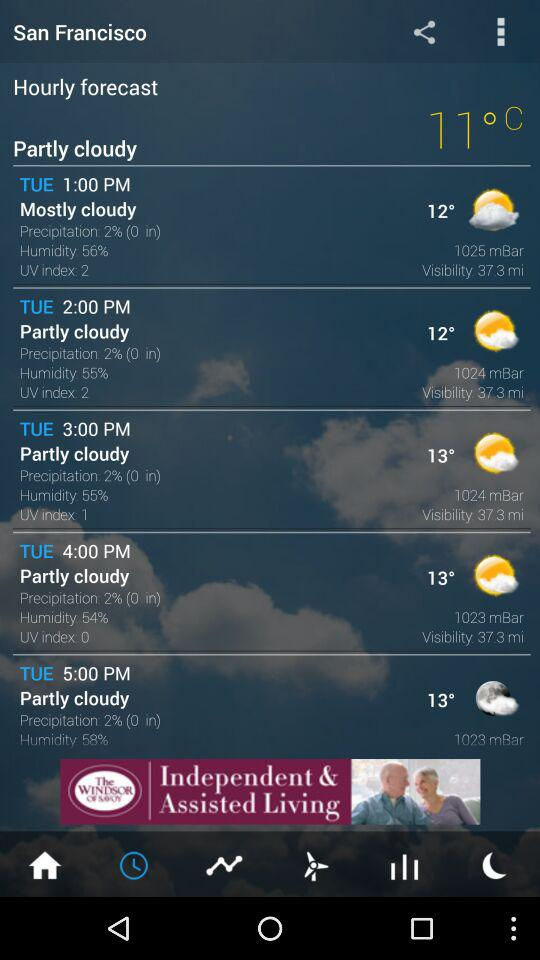What is the temperature on Tuesday at 3:00 PM? The temperature is 13°. 